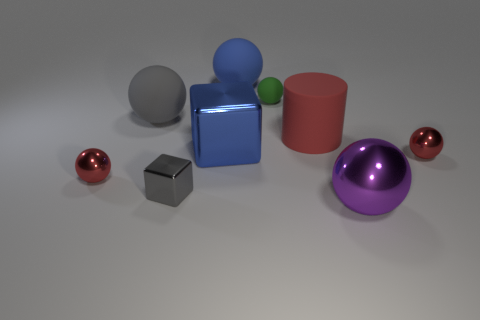Subtract all red spheres. How many spheres are left? 4 Subtract all blue balls. How many balls are left? 5 Subtract all cyan spheres. Subtract all gray blocks. How many spheres are left? 6 Add 1 red rubber cylinders. How many objects exist? 10 Subtract all blocks. How many objects are left? 7 Add 5 large red rubber cylinders. How many large red rubber cylinders are left? 6 Add 9 red matte cylinders. How many red matte cylinders exist? 10 Subtract 1 gray blocks. How many objects are left? 8 Subtract all big purple metallic cylinders. Subtract all gray objects. How many objects are left? 7 